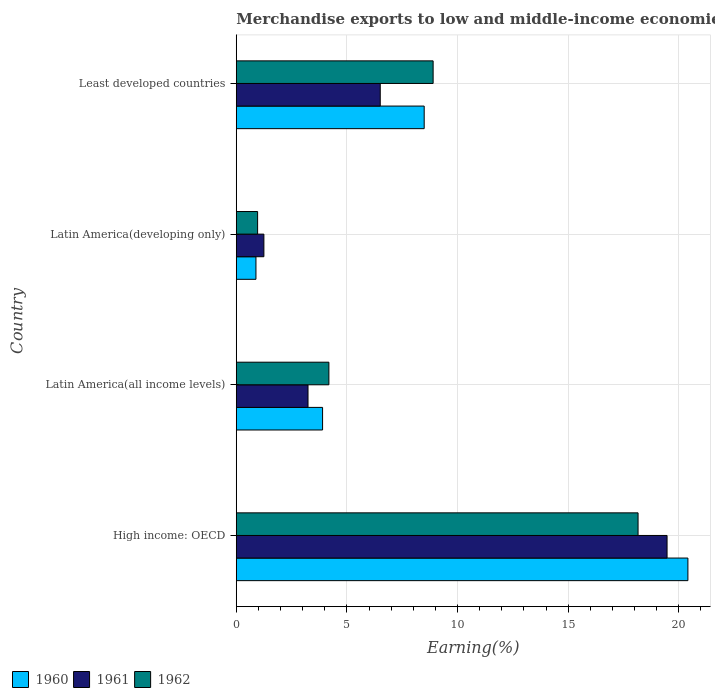Are the number of bars per tick equal to the number of legend labels?
Your answer should be compact. Yes. Are the number of bars on each tick of the Y-axis equal?
Make the answer very short. Yes. How many bars are there on the 2nd tick from the bottom?
Your response must be concise. 3. What is the label of the 4th group of bars from the top?
Provide a succinct answer. High income: OECD. What is the percentage of amount earned from merchandise exports in 1962 in Least developed countries?
Provide a succinct answer. 8.9. Across all countries, what is the maximum percentage of amount earned from merchandise exports in 1960?
Your answer should be compact. 20.41. Across all countries, what is the minimum percentage of amount earned from merchandise exports in 1962?
Your answer should be compact. 0.97. In which country was the percentage of amount earned from merchandise exports in 1962 maximum?
Make the answer very short. High income: OECD. In which country was the percentage of amount earned from merchandise exports in 1961 minimum?
Offer a very short reply. Latin America(developing only). What is the total percentage of amount earned from merchandise exports in 1961 in the graph?
Offer a very short reply. 30.47. What is the difference between the percentage of amount earned from merchandise exports in 1960 in Latin America(all income levels) and that in Latin America(developing only)?
Your answer should be compact. 3.01. What is the difference between the percentage of amount earned from merchandise exports in 1961 in Latin America(all income levels) and the percentage of amount earned from merchandise exports in 1960 in Least developed countries?
Your response must be concise. -5.25. What is the average percentage of amount earned from merchandise exports in 1961 per country?
Your response must be concise. 7.62. What is the difference between the percentage of amount earned from merchandise exports in 1960 and percentage of amount earned from merchandise exports in 1961 in Least developed countries?
Provide a short and direct response. 1.99. In how many countries, is the percentage of amount earned from merchandise exports in 1962 greater than 2 %?
Ensure brevity in your answer.  3. What is the ratio of the percentage of amount earned from merchandise exports in 1962 in High income: OECD to that in Latin America(all income levels)?
Your response must be concise. 4.34. Is the percentage of amount earned from merchandise exports in 1961 in High income: OECD less than that in Latin America(developing only)?
Provide a short and direct response. No. What is the difference between the highest and the second highest percentage of amount earned from merchandise exports in 1960?
Provide a succinct answer. 11.92. What is the difference between the highest and the lowest percentage of amount earned from merchandise exports in 1961?
Provide a short and direct response. 18.22. Is the sum of the percentage of amount earned from merchandise exports in 1962 in High income: OECD and Latin America(all income levels) greater than the maximum percentage of amount earned from merchandise exports in 1960 across all countries?
Make the answer very short. Yes. What does the 1st bar from the top in Latin America(all income levels) represents?
Provide a succinct answer. 1962. What does the 3rd bar from the bottom in Least developed countries represents?
Make the answer very short. 1962. Is it the case that in every country, the sum of the percentage of amount earned from merchandise exports in 1962 and percentage of amount earned from merchandise exports in 1961 is greater than the percentage of amount earned from merchandise exports in 1960?
Your answer should be compact. Yes. How many bars are there?
Your answer should be very brief. 12. Are all the bars in the graph horizontal?
Your answer should be compact. Yes. How many countries are there in the graph?
Your answer should be very brief. 4. Does the graph contain any zero values?
Offer a terse response. No. Does the graph contain grids?
Ensure brevity in your answer.  Yes. How many legend labels are there?
Make the answer very short. 3. What is the title of the graph?
Your answer should be compact. Merchandise exports to low and middle-income economies outside region. Does "1965" appear as one of the legend labels in the graph?
Give a very brief answer. No. What is the label or title of the X-axis?
Your answer should be compact. Earning(%). What is the Earning(%) in 1960 in High income: OECD?
Offer a very short reply. 20.41. What is the Earning(%) of 1961 in High income: OECD?
Your answer should be very brief. 19.47. What is the Earning(%) in 1962 in High income: OECD?
Your response must be concise. 18.16. What is the Earning(%) of 1960 in Latin America(all income levels)?
Your answer should be very brief. 3.9. What is the Earning(%) in 1961 in Latin America(all income levels)?
Your response must be concise. 3.24. What is the Earning(%) of 1962 in Latin America(all income levels)?
Your answer should be very brief. 4.19. What is the Earning(%) of 1960 in Latin America(developing only)?
Make the answer very short. 0.89. What is the Earning(%) in 1961 in Latin America(developing only)?
Give a very brief answer. 1.25. What is the Earning(%) of 1962 in Latin America(developing only)?
Make the answer very short. 0.97. What is the Earning(%) in 1960 in Least developed countries?
Give a very brief answer. 8.49. What is the Earning(%) in 1961 in Least developed countries?
Provide a succinct answer. 6.51. What is the Earning(%) in 1962 in Least developed countries?
Provide a succinct answer. 8.9. Across all countries, what is the maximum Earning(%) of 1960?
Ensure brevity in your answer.  20.41. Across all countries, what is the maximum Earning(%) of 1961?
Provide a short and direct response. 19.47. Across all countries, what is the maximum Earning(%) of 1962?
Give a very brief answer. 18.16. Across all countries, what is the minimum Earning(%) in 1960?
Give a very brief answer. 0.89. Across all countries, what is the minimum Earning(%) in 1961?
Your response must be concise. 1.25. Across all countries, what is the minimum Earning(%) in 1962?
Keep it short and to the point. 0.97. What is the total Earning(%) in 1960 in the graph?
Offer a terse response. 33.7. What is the total Earning(%) in 1961 in the graph?
Ensure brevity in your answer.  30.47. What is the total Earning(%) in 1962 in the graph?
Your answer should be very brief. 32.21. What is the difference between the Earning(%) in 1960 in High income: OECD and that in Latin America(all income levels)?
Your answer should be very brief. 16.51. What is the difference between the Earning(%) in 1961 in High income: OECD and that in Latin America(all income levels)?
Your response must be concise. 16.23. What is the difference between the Earning(%) in 1962 in High income: OECD and that in Latin America(all income levels)?
Your response must be concise. 13.97. What is the difference between the Earning(%) of 1960 in High income: OECD and that in Latin America(developing only)?
Ensure brevity in your answer.  19.52. What is the difference between the Earning(%) in 1961 in High income: OECD and that in Latin America(developing only)?
Keep it short and to the point. 18.22. What is the difference between the Earning(%) in 1962 in High income: OECD and that in Latin America(developing only)?
Give a very brief answer. 17.19. What is the difference between the Earning(%) in 1960 in High income: OECD and that in Least developed countries?
Make the answer very short. 11.92. What is the difference between the Earning(%) of 1961 in High income: OECD and that in Least developed countries?
Provide a succinct answer. 12.96. What is the difference between the Earning(%) in 1962 in High income: OECD and that in Least developed countries?
Provide a succinct answer. 9.26. What is the difference between the Earning(%) of 1960 in Latin America(all income levels) and that in Latin America(developing only)?
Offer a very short reply. 3.01. What is the difference between the Earning(%) in 1961 in Latin America(all income levels) and that in Latin America(developing only)?
Offer a terse response. 1.99. What is the difference between the Earning(%) in 1962 in Latin America(all income levels) and that in Latin America(developing only)?
Your answer should be very brief. 3.22. What is the difference between the Earning(%) in 1960 in Latin America(all income levels) and that in Least developed countries?
Give a very brief answer. -4.59. What is the difference between the Earning(%) of 1961 in Latin America(all income levels) and that in Least developed countries?
Offer a very short reply. -3.26. What is the difference between the Earning(%) of 1962 in Latin America(all income levels) and that in Least developed countries?
Your answer should be very brief. -4.71. What is the difference between the Earning(%) of 1960 in Latin America(developing only) and that in Least developed countries?
Provide a succinct answer. -7.6. What is the difference between the Earning(%) in 1961 in Latin America(developing only) and that in Least developed countries?
Ensure brevity in your answer.  -5.26. What is the difference between the Earning(%) in 1962 in Latin America(developing only) and that in Least developed countries?
Your answer should be very brief. -7.93. What is the difference between the Earning(%) of 1960 in High income: OECD and the Earning(%) of 1961 in Latin America(all income levels)?
Your answer should be very brief. 17.17. What is the difference between the Earning(%) of 1960 in High income: OECD and the Earning(%) of 1962 in Latin America(all income levels)?
Ensure brevity in your answer.  16.23. What is the difference between the Earning(%) of 1961 in High income: OECD and the Earning(%) of 1962 in Latin America(all income levels)?
Give a very brief answer. 15.28. What is the difference between the Earning(%) in 1960 in High income: OECD and the Earning(%) in 1961 in Latin America(developing only)?
Make the answer very short. 19.16. What is the difference between the Earning(%) in 1960 in High income: OECD and the Earning(%) in 1962 in Latin America(developing only)?
Your response must be concise. 19.45. What is the difference between the Earning(%) in 1961 in High income: OECD and the Earning(%) in 1962 in Latin America(developing only)?
Your response must be concise. 18.5. What is the difference between the Earning(%) in 1960 in High income: OECD and the Earning(%) in 1961 in Least developed countries?
Give a very brief answer. 13.9. What is the difference between the Earning(%) of 1960 in High income: OECD and the Earning(%) of 1962 in Least developed countries?
Your answer should be compact. 11.51. What is the difference between the Earning(%) of 1961 in High income: OECD and the Earning(%) of 1962 in Least developed countries?
Offer a very short reply. 10.57. What is the difference between the Earning(%) in 1960 in Latin America(all income levels) and the Earning(%) in 1961 in Latin America(developing only)?
Keep it short and to the point. 2.65. What is the difference between the Earning(%) of 1960 in Latin America(all income levels) and the Earning(%) of 1962 in Latin America(developing only)?
Your response must be concise. 2.94. What is the difference between the Earning(%) of 1961 in Latin America(all income levels) and the Earning(%) of 1962 in Latin America(developing only)?
Your answer should be very brief. 2.28. What is the difference between the Earning(%) in 1960 in Latin America(all income levels) and the Earning(%) in 1961 in Least developed countries?
Your answer should be very brief. -2.61. What is the difference between the Earning(%) of 1960 in Latin America(all income levels) and the Earning(%) of 1962 in Least developed countries?
Provide a succinct answer. -5. What is the difference between the Earning(%) in 1961 in Latin America(all income levels) and the Earning(%) in 1962 in Least developed countries?
Ensure brevity in your answer.  -5.65. What is the difference between the Earning(%) of 1960 in Latin America(developing only) and the Earning(%) of 1961 in Least developed countries?
Keep it short and to the point. -5.62. What is the difference between the Earning(%) in 1960 in Latin America(developing only) and the Earning(%) in 1962 in Least developed countries?
Ensure brevity in your answer.  -8.01. What is the difference between the Earning(%) in 1961 in Latin America(developing only) and the Earning(%) in 1962 in Least developed countries?
Your answer should be very brief. -7.65. What is the average Earning(%) of 1960 per country?
Provide a succinct answer. 8.42. What is the average Earning(%) of 1961 per country?
Keep it short and to the point. 7.62. What is the average Earning(%) of 1962 per country?
Your answer should be very brief. 8.05. What is the difference between the Earning(%) in 1960 and Earning(%) in 1961 in High income: OECD?
Offer a very short reply. 0.94. What is the difference between the Earning(%) of 1960 and Earning(%) of 1962 in High income: OECD?
Offer a terse response. 2.25. What is the difference between the Earning(%) of 1961 and Earning(%) of 1962 in High income: OECD?
Ensure brevity in your answer.  1.31. What is the difference between the Earning(%) in 1960 and Earning(%) in 1961 in Latin America(all income levels)?
Make the answer very short. 0.66. What is the difference between the Earning(%) of 1960 and Earning(%) of 1962 in Latin America(all income levels)?
Provide a short and direct response. -0.29. What is the difference between the Earning(%) of 1961 and Earning(%) of 1962 in Latin America(all income levels)?
Your response must be concise. -0.94. What is the difference between the Earning(%) of 1960 and Earning(%) of 1961 in Latin America(developing only)?
Your response must be concise. -0.36. What is the difference between the Earning(%) in 1960 and Earning(%) in 1962 in Latin America(developing only)?
Your answer should be compact. -0.07. What is the difference between the Earning(%) of 1961 and Earning(%) of 1962 in Latin America(developing only)?
Provide a short and direct response. 0.28. What is the difference between the Earning(%) of 1960 and Earning(%) of 1961 in Least developed countries?
Make the answer very short. 1.99. What is the difference between the Earning(%) in 1960 and Earning(%) in 1962 in Least developed countries?
Make the answer very short. -0.4. What is the difference between the Earning(%) of 1961 and Earning(%) of 1962 in Least developed countries?
Your response must be concise. -2.39. What is the ratio of the Earning(%) of 1960 in High income: OECD to that in Latin America(all income levels)?
Keep it short and to the point. 5.23. What is the ratio of the Earning(%) of 1961 in High income: OECD to that in Latin America(all income levels)?
Your answer should be very brief. 6. What is the ratio of the Earning(%) in 1962 in High income: OECD to that in Latin America(all income levels)?
Your response must be concise. 4.34. What is the ratio of the Earning(%) in 1960 in High income: OECD to that in Latin America(developing only)?
Ensure brevity in your answer.  22.92. What is the ratio of the Earning(%) of 1961 in High income: OECD to that in Latin America(developing only)?
Make the answer very short. 15.59. What is the ratio of the Earning(%) in 1962 in High income: OECD to that in Latin America(developing only)?
Make the answer very short. 18.82. What is the ratio of the Earning(%) of 1960 in High income: OECD to that in Least developed countries?
Offer a very short reply. 2.4. What is the ratio of the Earning(%) of 1961 in High income: OECD to that in Least developed countries?
Give a very brief answer. 2.99. What is the ratio of the Earning(%) of 1962 in High income: OECD to that in Least developed countries?
Give a very brief answer. 2.04. What is the ratio of the Earning(%) of 1960 in Latin America(all income levels) to that in Latin America(developing only)?
Give a very brief answer. 4.38. What is the ratio of the Earning(%) of 1961 in Latin America(all income levels) to that in Latin America(developing only)?
Your answer should be compact. 2.6. What is the ratio of the Earning(%) in 1962 in Latin America(all income levels) to that in Latin America(developing only)?
Offer a very short reply. 4.34. What is the ratio of the Earning(%) in 1960 in Latin America(all income levels) to that in Least developed countries?
Your answer should be compact. 0.46. What is the ratio of the Earning(%) in 1961 in Latin America(all income levels) to that in Least developed countries?
Give a very brief answer. 0.5. What is the ratio of the Earning(%) of 1962 in Latin America(all income levels) to that in Least developed countries?
Offer a very short reply. 0.47. What is the ratio of the Earning(%) of 1960 in Latin America(developing only) to that in Least developed countries?
Your answer should be compact. 0.1. What is the ratio of the Earning(%) of 1961 in Latin America(developing only) to that in Least developed countries?
Make the answer very short. 0.19. What is the ratio of the Earning(%) in 1962 in Latin America(developing only) to that in Least developed countries?
Give a very brief answer. 0.11. What is the difference between the highest and the second highest Earning(%) of 1960?
Give a very brief answer. 11.92. What is the difference between the highest and the second highest Earning(%) in 1961?
Your response must be concise. 12.96. What is the difference between the highest and the second highest Earning(%) in 1962?
Ensure brevity in your answer.  9.26. What is the difference between the highest and the lowest Earning(%) in 1960?
Provide a succinct answer. 19.52. What is the difference between the highest and the lowest Earning(%) in 1961?
Provide a succinct answer. 18.22. What is the difference between the highest and the lowest Earning(%) of 1962?
Offer a terse response. 17.19. 